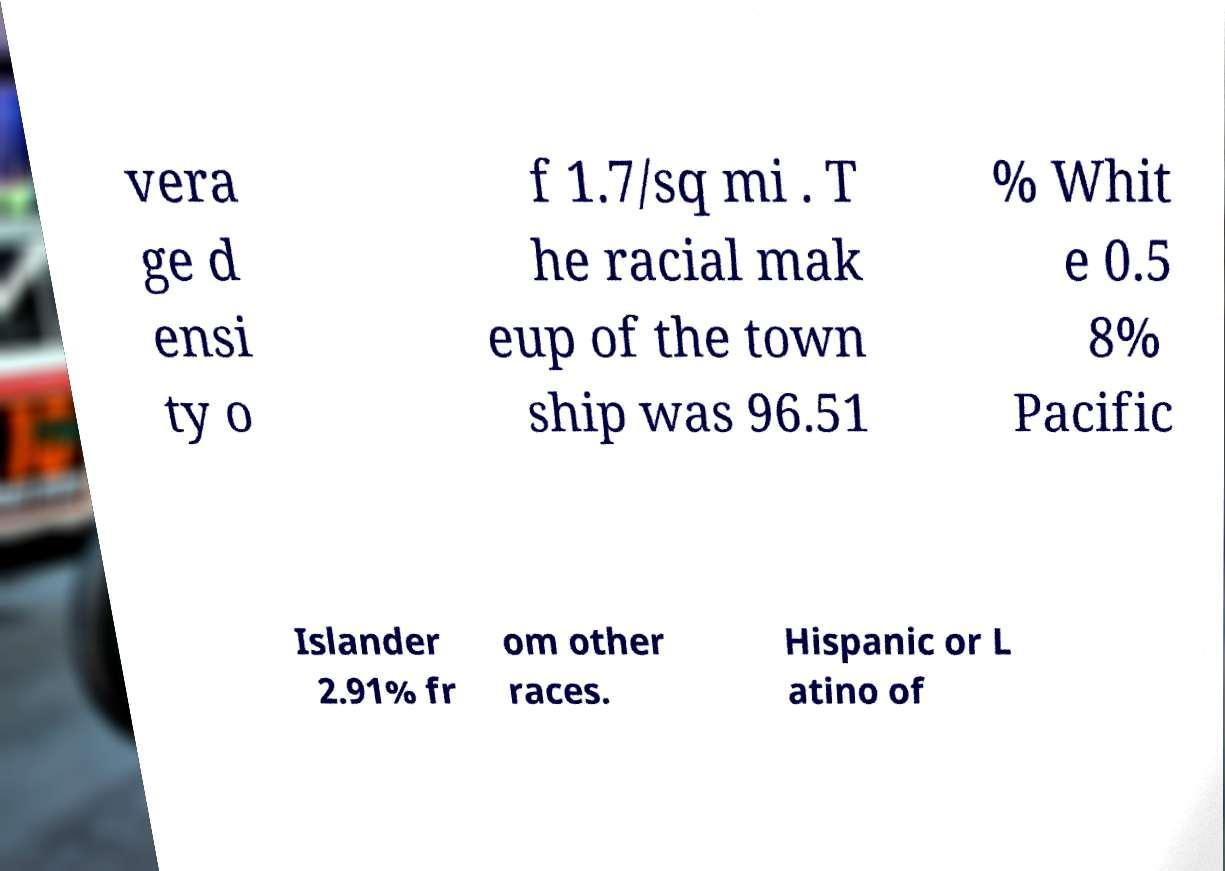Could you extract and type out the text from this image? vera ge d ensi ty o f 1.7/sq mi . T he racial mak eup of the town ship was 96.51 % Whit e 0.5 8% Pacific Islander 2.91% fr om other races. Hispanic or L atino of 